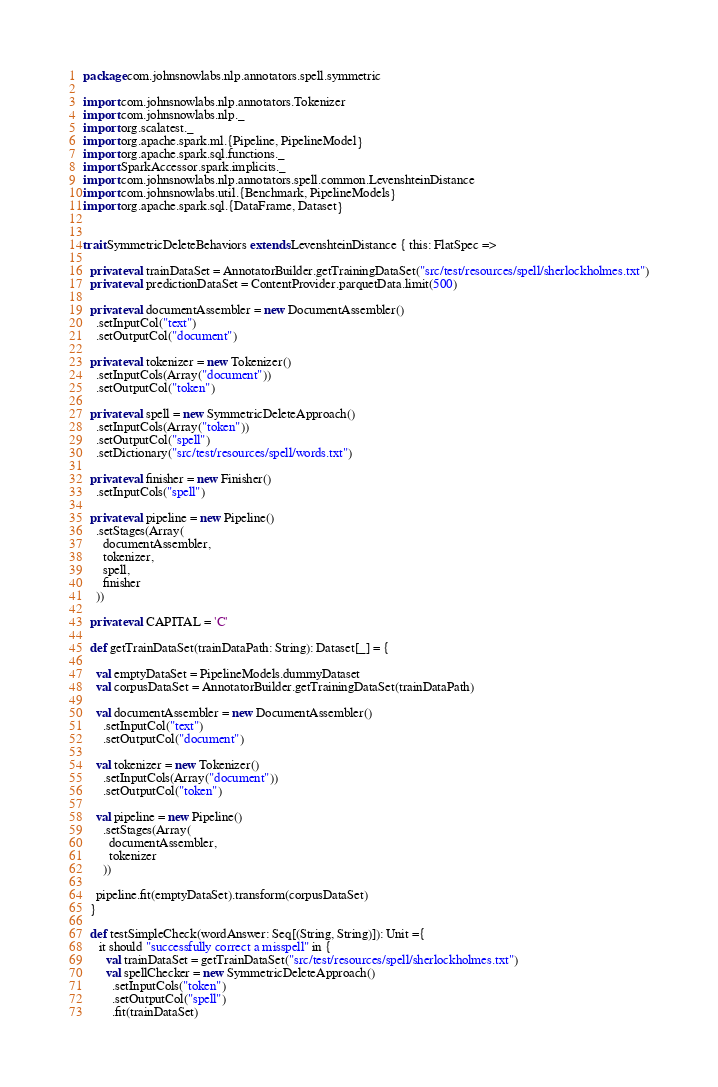<code> <loc_0><loc_0><loc_500><loc_500><_Scala_>package com.johnsnowlabs.nlp.annotators.spell.symmetric

import com.johnsnowlabs.nlp.annotators.Tokenizer
import com.johnsnowlabs.nlp._
import org.scalatest._
import org.apache.spark.ml.{Pipeline, PipelineModel}
import org.apache.spark.sql.functions._
import SparkAccessor.spark.implicits._
import com.johnsnowlabs.nlp.annotators.spell.common.LevenshteinDistance
import com.johnsnowlabs.util.{Benchmark, PipelineModels}
import org.apache.spark.sql.{DataFrame, Dataset}


trait SymmetricDeleteBehaviors extends LevenshteinDistance { this: FlatSpec =>

  private val trainDataSet = AnnotatorBuilder.getTrainingDataSet("src/test/resources/spell/sherlockholmes.txt")
  private val predictionDataSet = ContentProvider.parquetData.limit(500)

  private val documentAssembler = new DocumentAssembler()
    .setInputCol("text")
    .setOutputCol("document")

  private val tokenizer = new Tokenizer()
    .setInputCols(Array("document"))
    .setOutputCol("token")

  private val spell = new SymmetricDeleteApproach()
    .setInputCols(Array("token"))
    .setOutputCol("spell")
    .setDictionary("src/test/resources/spell/words.txt")

  private val finisher = new Finisher()
    .setInputCols("spell")

  private val pipeline = new Pipeline()
    .setStages(Array(
      documentAssembler,
      tokenizer,
      spell,
      finisher
    ))

  private val CAPITAL = 'C'

  def getTrainDataSet(trainDataPath: String): Dataset[_] = {

    val emptyDataSet = PipelineModels.dummyDataset
    val corpusDataSet = AnnotatorBuilder.getTrainingDataSet(trainDataPath)

    val documentAssembler = new DocumentAssembler()
      .setInputCol("text")
      .setOutputCol("document")

    val tokenizer = new Tokenizer()
      .setInputCols(Array("document"))
      .setOutputCol("token")

    val pipeline = new Pipeline()
      .setStages(Array(
        documentAssembler,
        tokenizer
      ))

    pipeline.fit(emptyDataSet).transform(corpusDataSet)
  }

  def testSimpleCheck(wordAnswer: Seq[(String, String)]): Unit ={
     it should "successfully correct a misspell" in {
       val trainDataSet = getTrainDataSet("src/test/resources/spell/sherlockholmes.txt")
       val spellChecker = new SymmetricDeleteApproach()
         .setInputCols("token")
         .setOutputCol("spell")
         .fit(trainDataSet)</code> 